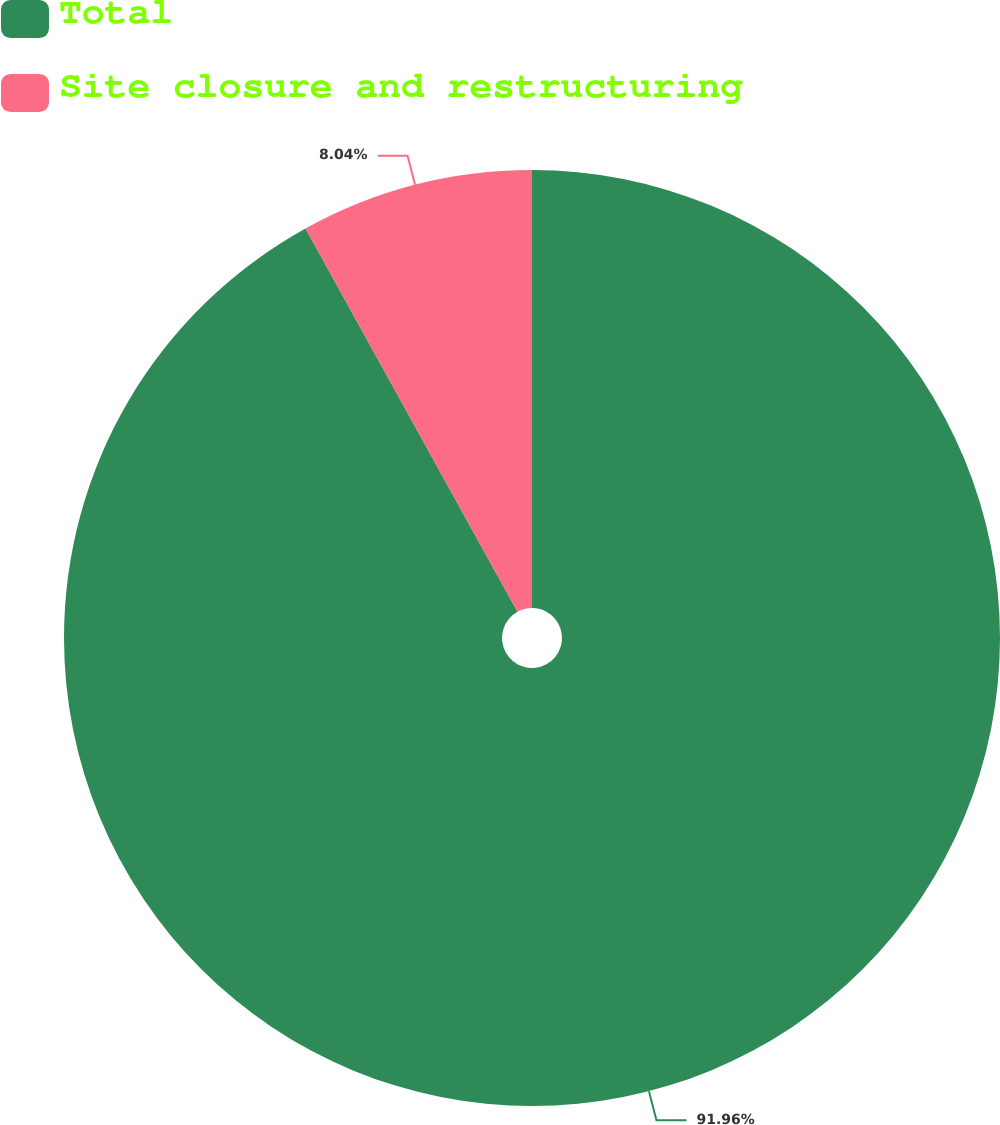<chart> <loc_0><loc_0><loc_500><loc_500><pie_chart><fcel>Total<fcel>Site closure and restructuring<nl><fcel>91.96%<fcel>8.04%<nl></chart> 